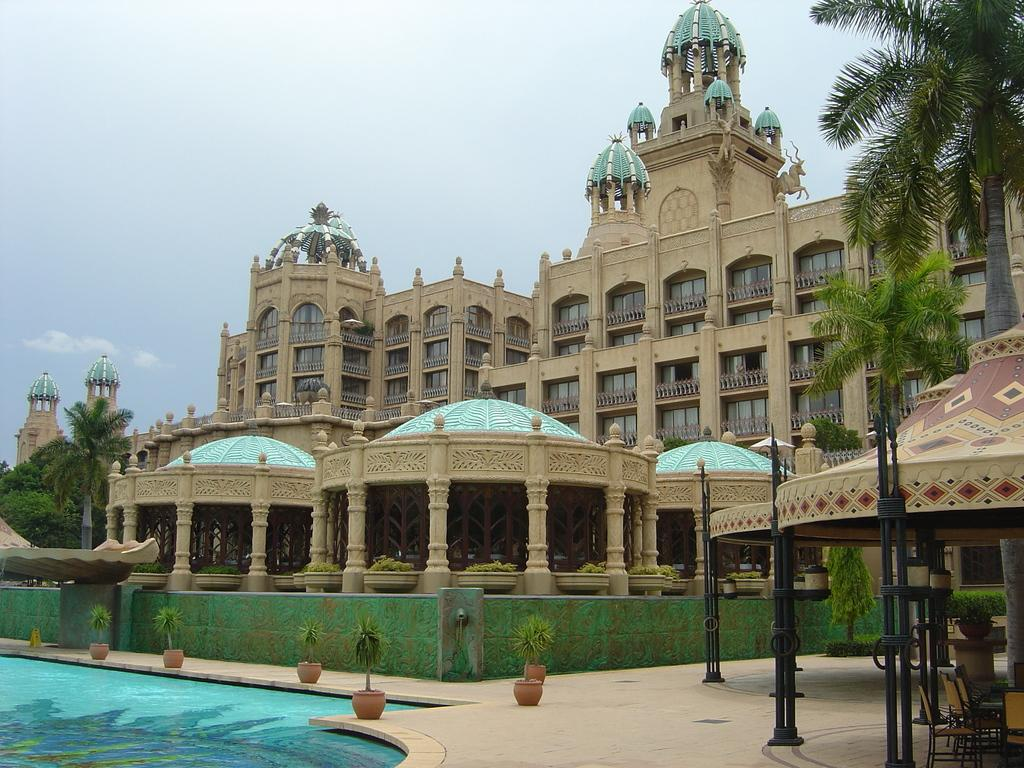What is the primary element visible in the image? There is water in the image. What type of plants can be seen in the image? There are houseplants in the image. What type of furniture is present on the ground? Chairs are present on the ground. What can be seen in the background of the image? There is a building, trees, and the sky visible in the background of the image. What flavor of toy can be seen floating in the water? There are no toys present in the image, and therefore no flavor can be associated with them. 